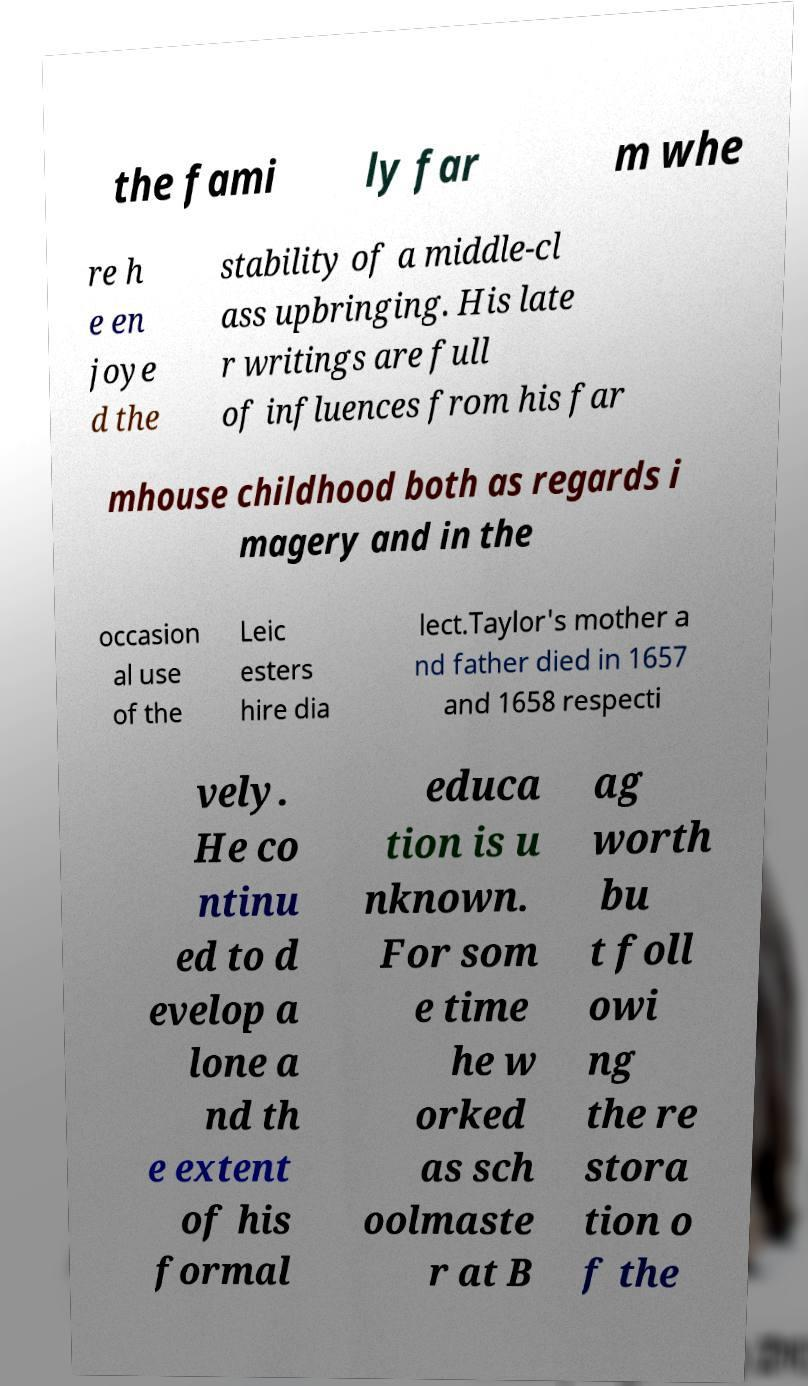Please read and relay the text visible in this image. What does it say? the fami ly far m whe re h e en joye d the stability of a middle-cl ass upbringing. His late r writings are full of influences from his far mhouse childhood both as regards i magery and in the occasion al use of the Leic esters hire dia lect.Taylor's mother a nd father died in 1657 and 1658 respecti vely. He co ntinu ed to d evelop a lone a nd th e extent of his formal educa tion is u nknown. For som e time he w orked as sch oolmaste r at B ag worth bu t foll owi ng the re stora tion o f the 